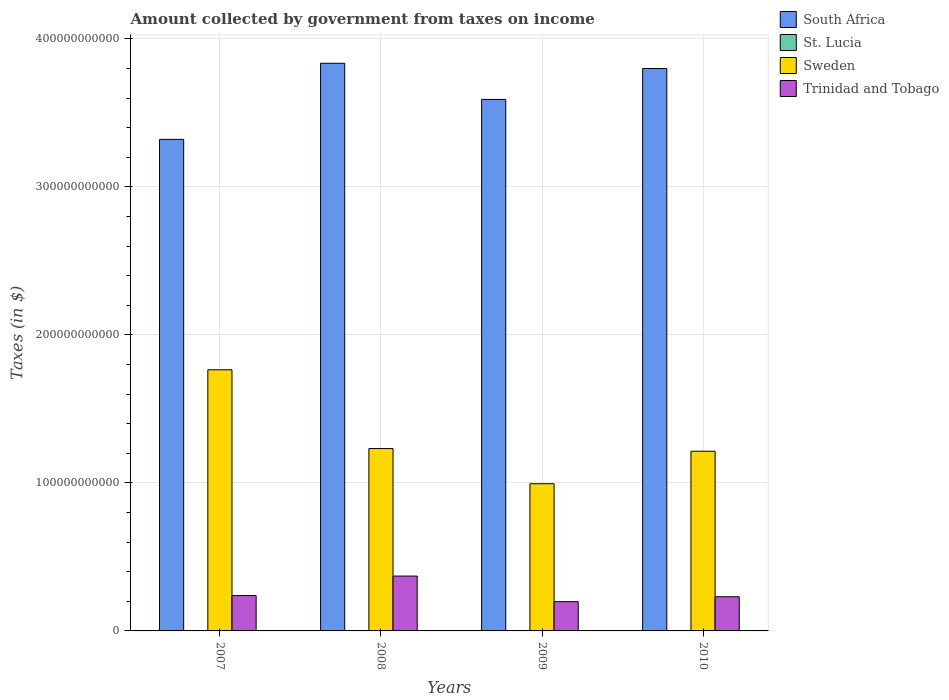How many groups of bars are there?
Offer a terse response. 4. Are the number of bars per tick equal to the number of legend labels?
Make the answer very short. Yes. Are the number of bars on each tick of the X-axis equal?
Ensure brevity in your answer.  Yes. How many bars are there on the 4th tick from the right?
Provide a succinct answer. 4. In how many cases, is the number of bars for a given year not equal to the number of legend labels?
Your answer should be compact. 0. What is the amount collected by government from taxes on income in St. Lucia in 2009?
Offer a terse response. 2.26e+08. Across all years, what is the maximum amount collected by government from taxes on income in Trinidad and Tobago?
Give a very brief answer. 3.71e+1. Across all years, what is the minimum amount collected by government from taxes on income in South Africa?
Offer a terse response. 3.32e+11. In which year was the amount collected by government from taxes on income in South Africa maximum?
Ensure brevity in your answer.  2008. What is the total amount collected by government from taxes on income in St. Lucia in the graph?
Provide a succinct answer. 8.52e+08. What is the difference between the amount collected by government from taxes on income in Sweden in 2007 and that in 2008?
Offer a very short reply. 5.32e+1. What is the difference between the amount collected by government from taxes on income in Sweden in 2010 and the amount collected by government from taxes on income in South Africa in 2009?
Provide a short and direct response. -2.38e+11. What is the average amount collected by government from taxes on income in South Africa per year?
Your response must be concise. 3.64e+11. In the year 2007, what is the difference between the amount collected by government from taxes on income in Trinidad and Tobago and amount collected by government from taxes on income in Sweden?
Provide a succinct answer. -1.53e+11. In how many years, is the amount collected by government from taxes on income in Trinidad and Tobago greater than 280000000000 $?
Offer a very short reply. 0. What is the ratio of the amount collected by government from taxes on income in Trinidad and Tobago in 2007 to that in 2009?
Keep it short and to the point. 1.21. What is the difference between the highest and the second highest amount collected by government from taxes on income in South Africa?
Make the answer very short. 3.54e+09. What is the difference between the highest and the lowest amount collected by government from taxes on income in Trinidad and Tobago?
Your answer should be compact. 1.73e+1. In how many years, is the amount collected by government from taxes on income in South Africa greater than the average amount collected by government from taxes on income in South Africa taken over all years?
Provide a succinct answer. 2. Is the sum of the amount collected by government from taxes on income in St. Lucia in 2009 and 2010 greater than the maximum amount collected by government from taxes on income in Sweden across all years?
Provide a short and direct response. No. What does the 4th bar from the left in 2008 represents?
Your answer should be very brief. Trinidad and Tobago. What does the 3rd bar from the right in 2010 represents?
Offer a very short reply. St. Lucia. Is it the case that in every year, the sum of the amount collected by government from taxes on income in Trinidad and Tobago and amount collected by government from taxes on income in South Africa is greater than the amount collected by government from taxes on income in Sweden?
Provide a short and direct response. Yes. How many bars are there?
Provide a succinct answer. 16. Are all the bars in the graph horizontal?
Provide a succinct answer. No. What is the difference between two consecutive major ticks on the Y-axis?
Your answer should be very brief. 1.00e+11. Does the graph contain any zero values?
Your answer should be compact. No. Where does the legend appear in the graph?
Offer a very short reply. Top right. What is the title of the graph?
Ensure brevity in your answer.  Amount collected by government from taxes on income. What is the label or title of the X-axis?
Offer a terse response. Years. What is the label or title of the Y-axis?
Your answer should be very brief. Taxes (in $). What is the Taxes (in $) of South Africa in 2007?
Keep it short and to the point. 3.32e+11. What is the Taxes (in $) in St. Lucia in 2007?
Provide a succinct answer. 1.77e+08. What is the Taxes (in $) in Sweden in 2007?
Your answer should be compact. 1.76e+11. What is the Taxes (in $) in Trinidad and Tobago in 2007?
Offer a terse response. 2.39e+1. What is the Taxes (in $) in South Africa in 2008?
Your answer should be very brief. 3.83e+11. What is the Taxes (in $) of St. Lucia in 2008?
Keep it short and to the point. 2.26e+08. What is the Taxes (in $) of Sweden in 2008?
Your answer should be compact. 1.23e+11. What is the Taxes (in $) in Trinidad and Tobago in 2008?
Offer a very short reply. 3.71e+1. What is the Taxes (in $) in South Africa in 2009?
Your answer should be compact. 3.59e+11. What is the Taxes (in $) of St. Lucia in 2009?
Your answer should be compact. 2.26e+08. What is the Taxes (in $) of Sweden in 2009?
Give a very brief answer. 9.94e+1. What is the Taxes (in $) in Trinidad and Tobago in 2009?
Your answer should be very brief. 1.98e+1. What is the Taxes (in $) of South Africa in 2010?
Provide a short and direct response. 3.80e+11. What is the Taxes (in $) of St. Lucia in 2010?
Make the answer very short. 2.23e+08. What is the Taxes (in $) in Sweden in 2010?
Offer a terse response. 1.21e+11. What is the Taxes (in $) in Trinidad and Tobago in 2010?
Offer a terse response. 2.31e+1. Across all years, what is the maximum Taxes (in $) of South Africa?
Provide a succinct answer. 3.83e+11. Across all years, what is the maximum Taxes (in $) of St. Lucia?
Offer a terse response. 2.26e+08. Across all years, what is the maximum Taxes (in $) of Sweden?
Your answer should be compact. 1.76e+11. Across all years, what is the maximum Taxes (in $) of Trinidad and Tobago?
Provide a short and direct response. 3.71e+1. Across all years, what is the minimum Taxes (in $) of South Africa?
Ensure brevity in your answer.  3.32e+11. Across all years, what is the minimum Taxes (in $) of St. Lucia?
Your response must be concise. 1.77e+08. Across all years, what is the minimum Taxes (in $) in Sweden?
Give a very brief answer. 9.94e+1. Across all years, what is the minimum Taxes (in $) of Trinidad and Tobago?
Ensure brevity in your answer.  1.98e+1. What is the total Taxes (in $) in South Africa in the graph?
Your answer should be very brief. 1.45e+12. What is the total Taxes (in $) in St. Lucia in the graph?
Keep it short and to the point. 8.52e+08. What is the total Taxes (in $) in Sweden in the graph?
Make the answer very short. 5.20e+11. What is the total Taxes (in $) in Trinidad and Tobago in the graph?
Your response must be concise. 1.04e+11. What is the difference between the Taxes (in $) of South Africa in 2007 and that in 2008?
Ensure brevity in your answer.  -5.14e+1. What is the difference between the Taxes (in $) in St. Lucia in 2007 and that in 2008?
Your answer should be very brief. -4.91e+07. What is the difference between the Taxes (in $) of Sweden in 2007 and that in 2008?
Your answer should be compact. 5.32e+1. What is the difference between the Taxes (in $) in Trinidad and Tobago in 2007 and that in 2008?
Your response must be concise. -1.32e+1. What is the difference between the Taxes (in $) in South Africa in 2007 and that in 2009?
Offer a terse response. -2.70e+1. What is the difference between the Taxes (in $) of St. Lucia in 2007 and that in 2009?
Your answer should be compact. -4.97e+07. What is the difference between the Taxes (in $) in Sweden in 2007 and that in 2009?
Offer a very short reply. 7.70e+1. What is the difference between the Taxes (in $) of Trinidad and Tobago in 2007 and that in 2009?
Make the answer very short. 4.14e+09. What is the difference between the Taxes (in $) in South Africa in 2007 and that in 2010?
Your answer should be very brief. -4.79e+1. What is the difference between the Taxes (in $) in St. Lucia in 2007 and that in 2010?
Offer a very short reply. -4.66e+07. What is the difference between the Taxes (in $) in Sweden in 2007 and that in 2010?
Make the answer very short. 5.50e+1. What is the difference between the Taxes (in $) of Trinidad and Tobago in 2007 and that in 2010?
Keep it short and to the point. 8.19e+08. What is the difference between the Taxes (in $) of South Africa in 2008 and that in 2009?
Your answer should be very brief. 2.44e+1. What is the difference between the Taxes (in $) of St. Lucia in 2008 and that in 2009?
Your answer should be compact. -6.00e+05. What is the difference between the Taxes (in $) in Sweden in 2008 and that in 2009?
Give a very brief answer. 2.38e+1. What is the difference between the Taxes (in $) in Trinidad and Tobago in 2008 and that in 2009?
Ensure brevity in your answer.  1.73e+1. What is the difference between the Taxes (in $) in South Africa in 2008 and that in 2010?
Ensure brevity in your answer.  3.54e+09. What is the difference between the Taxes (in $) of St. Lucia in 2008 and that in 2010?
Your answer should be compact. 2.50e+06. What is the difference between the Taxes (in $) of Sweden in 2008 and that in 2010?
Keep it short and to the point. 1.82e+09. What is the difference between the Taxes (in $) in Trinidad and Tobago in 2008 and that in 2010?
Offer a very short reply. 1.40e+1. What is the difference between the Taxes (in $) of South Africa in 2009 and that in 2010?
Give a very brief answer. -2.09e+1. What is the difference between the Taxes (in $) in St. Lucia in 2009 and that in 2010?
Your answer should be very brief. 3.10e+06. What is the difference between the Taxes (in $) of Sweden in 2009 and that in 2010?
Offer a very short reply. -2.20e+1. What is the difference between the Taxes (in $) of Trinidad and Tobago in 2009 and that in 2010?
Your answer should be compact. -3.32e+09. What is the difference between the Taxes (in $) of South Africa in 2007 and the Taxes (in $) of St. Lucia in 2008?
Keep it short and to the point. 3.32e+11. What is the difference between the Taxes (in $) in South Africa in 2007 and the Taxes (in $) in Sweden in 2008?
Your answer should be compact. 2.09e+11. What is the difference between the Taxes (in $) in South Africa in 2007 and the Taxes (in $) in Trinidad and Tobago in 2008?
Offer a terse response. 2.95e+11. What is the difference between the Taxes (in $) in St. Lucia in 2007 and the Taxes (in $) in Sweden in 2008?
Your answer should be compact. -1.23e+11. What is the difference between the Taxes (in $) of St. Lucia in 2007 and the Taxes (in $) of Trinidad and Tobago in 2008?
Ensure brevity in your answer.  -3.69e+1. What is the difference between the Taxes (in $) of Sweden in 2007 and the Taxes (in $) of Trinidad and Tobago in 2008?
Make the answer very short. 1.39e+11. What is the difference between the Taxes (in $) of South Africa in 2007 and the Taxes (in $) of St. Lucia in 2009?
Keep it short and to the point. 3.32e+11. What is the difference between the Taxes (in $) of South Africa in 2007 and the Taxes (in $) of Sweden in 2009?
Give a very brief answer. 2.33e+11. What is the difference between the Taxes (in $) in South Africa in 2007 and the Taxes (in $) in Trinidad and Tobago in 2009?
Your response must be concise. 3.12e+11. What is the difference between the Taxes (in $) of St. Lucia in 2007 and the Taxes (in $) of Sweden in 2009?
Offer a very short reply. -9.93e+1. What is the difference between the Taxes (in $) of St. Lucia in 2007 and the Taxes (in $) of Trinidad and Tobago in 2009?
Offer a very short reply. -1.96e+1. What is the difference between the Taxes (in $) in Sweden in 2007 and the Taxes (in $) in Trinidad and Tobago in 2009?
Keep it short and to the point. 1.57e+11. What is the difference between the Taxes (in $) in South Africa in 2007 and the Taxes (in $) in St. Lucia in 2010?
Offer a very short reply. 3.32e+11. What is the difference between the Taxes (in $) in South Africa in 2007 and the Taxes (in $) in Sweden in 2010?
Make the answer very short. 2.11e+11. What is the difference between the Taxes (in $) of South Africa in 2007 and the Taxes (in $) of Trinidad and Tobago in 2010?
Your answer should be compact. 3.09e+11. What is the difference between the Taxes (in $) of St. Lucia in 2007 and the Taxes (in $) of Sweden in 2010?
Give a very brief answer. -1.21e+11. What is the difference between the Taxes (in $) of St. Lucia in 2007 and the Taxes (in $) of Trinidad and Tobago in 2010?
Your answer should be compact. -2.29e+1. What is the difference between the Taxes (in $) in Sweden in 2007 and the Taxes (in $) in Trinidad and Tobago in 2010?
Keep it short and to the point. 1.53e+11. What is the difference between the Taxes (in $) in South Africa in 2008 and the Taxes (in $) in St. Lucia in 2009?
Ensure brevity in your answer.  3.83e+11. What is the difference between the Taxes (in $) of South Africa in 2008 and the Taxes (in $) of Sweden in 2009?
Your answer should be very brief. 2.84e+11. What is the difference between the Taxes (in $) of South Africa in 2008 and the Taxes (in $) of Trinidad and Tobago in 2009?
Your response must be concise. 3.64e+11. What is the difference between the Taxes (in $) in St. Lucia in 2008 and the Taxes (in $) in Sweden in 2009?
Offer a very short reply. -9.92e+1. What is the difference between the Taxes (in $) of St. Lucia in 2008 and the Taxes (in $) of Trinidad and Tobago in 2009?
Your response must be concise. -1.95e+1. What is the difference between the Taxes (in $) of Sweden in 2008 and the Taxes (in $) of Trinidad and Tobago in 2009?
Provide a succinct answer. 1.03e+11. What is the difference between the Taxes (in $) in South Africa in 2008 and the Taxes (in $) in St. Lucia in 2010?
Ensure brevity in your answer.  3.83e+11. What is the difference between the Taxes (in $) in South Africa in 2008 and the Taxes (in $) in Sweden in 2010?
Your answer should be very brief. 2.62e+11. What is the difference between the Taxes (in $) in South Africa in 2008 and the Taxes (in $) in Trinidad and Tobago in 2010?
Make the answer very short. 3.60e+11. What is the difference between the Taxes (in $) of St. Lucia in 2008 and the Taxes (in $) of Sweden in 2010?
Offer a very short reply. -1.21e+11. What is the difference between the Taxes (in $) of St. Lucia in 2008 and the Taxes (in $) of Trinidad and Tobago in 2010?
Offer a very short reply. -2.28e+1. What is the difference between the Taxes (in $) of Sweden in 2008 and the Taxes (in $) of Trinidad and Tobago in 2010?
Offer a terse response. 1.00e+11. What is the difference between the Taxes (in $) in South Africa in 2009 and the Taxes (in $) in St. Lucia in 2010?
Offer a terse response. 3.59e+11. What is the difference between the Taxes (in $) of South Africa in 2009 and the Taxes (in $) of Sweden in 2010?
Give a very brief answer. 2.38e+11. What is the difference between the Taxes (in $) in South Africa in 2009 and the Taxes (in $) in Trinidad and Tobago in 2010?
Keep it short and to the point. 3.36e+11. What is the difference between the Taxes (in $) in St. Lucia in 2009 and the Taxes (in $) in Sweden in 2010?
Provide a succinct answer. -1.21e+11. What is the difference between the Taxes (in $) of St. Lucia in 2009 and the Taxes (in $) of Trinidad and Tobago in 2010?
Offer a very short reply. -2.28e+1. What is the difference between the Taxes (in $) of Sweden in 2009 and the Taxes (in $) of Trinidad and Tobago in 2010?
Your response must be concise. 7.64e+1. What is the average Taxes (in $) of South Africa per year?
Offer a terse response. 3.64e+11. What is the average Taxes (in $) of St. Lucia per year?
Give a very brief answer. 2.13e+08. What is the average Taxes (in $) of Sweden per year?
Provide a succinct answer. 1.30e+11. What is the average Taxes (in $) of Trinidad and Tobago per year?
Keep it short and to the point. 2.59e+1. In the year 2007, what is the difference between the Taxes (in $) in South Africa and Taxes (in $) in St. Lucia?
Your answer should be very brief. 3.32e+11. In the year 2007, what is the difference between the Taxes (in $) of South Africa and Taxes (in $) of Sweden?
Make the answer very short. 1.56e+11. In the year 2007, what is the difference between the Taxes (in $) of South Africa and Taxes (in $) of Trinidad and Tobago?
Offer a very short reply. 3.08e+11. In the year 2007, what is the difference between the Taxes (in $) of St. Lucia and Taxes (in $) of Sweden?
Make the answer very short. -1.76e+11. In the year 2007, what is the difference between the Taxes (in $) of St. Lucia and Taxes (in $) of Trinidad and Tobago?
Your answer should be compact. -2.37e+1. In the year 2007, what is the difference between the Taxes (in $) in Sweden and Taxes (in $) in Trinidad and Tobago?
Your answer should be very brief. 1.53e+11. In the year 2008, what is the difference between the Taxes (in $) in South Africa and Taxes (in $) in St. Lucia?
Your answer should be compact. 3.83e+11. In the year 2008, what is the difference between the Taxes (in $) in South Africa and Taxes (in $) in Sweden?
Give a very brief answer. 2.60e+11. In the year 2008, what is the difference between the Taxes (in $) of South Africa and Taxes (in $) of Trinidad and Tobago?
Your answer should be very brief. 3.46e+11. In the year 2008, what is the difference between the Taxes (in $) in St. Lucia and Taxes (in $) in Sweden?
Offer a very short reply. -1.23e+11. In the year 2008, what is the difference between the Taxes (in $) of St. Lucia and Taxes (in $) of Trinidad and Tobago?
Your response must be concise. -3.68e+1. In the year 2008, what is the difference between the Taxes (in $) in Sweden and Taxes (in $) in Trinidad and Tobago?
Ensure brevity in your answer.  8.61e+1. In the year 2009, what is the difference between the Taxes (in $) in South Africa and Taxes (in $) in St. Lucia?
Give a very brief answer. 3.59e+11. In the year 2009, what is the difference between the Taxes (in $) of South Africa and Taxes (in $) of Sweden?
Give a very brief answer. 2.60e+11. In the year 2009, what is the difference between the Taxes (in $) in South Africa and Taxes (in $) in Trinidad and Tobago?
Your answer should be compact. 3.39e+11. In the year 2009, what is the difference between the Taxes (in $) of St. Lucia and Taxes (in $) of Sweden?
Ensure brevity in your answer.  -9.92e+1. In the year 2009, what is the difference between the Taxes (in $) in St. Lucia and Taxes (in $) in Trinidad and Tobago?
Provide a succinct answer. -1.95e+1. In the year 2009, what is the difference between the Taxes (in $) in Sweden and Taxes (in $) in Trinidad and Tobago?
Ensure brevity in your answer.  7.97e+1. In the year 2010, what is the difference between the Taxes (in $) of South Africa and Taxes (in $) of St. Lucia?
Your response must be concise. 3.80e+11. In the year 2010, what is the difference between the Taxes (in $) in South Africa and Taxes (in $) in Sweden?
Offer a terse response. 2.59e+11. In the year 2010, what is the difference between the Taxes (in $) of South Africa and Taxes (in $) of Trinidad and Tobago?
Offer a very short reply. 3.57e+11. In the year 2010, what is the difference between the Taxes (in $) in St. Lucia and Taxes (in $) in Sweden?
Your answer should be compact. -1.21e+11. In the year 2010, what is the difference between the Taxes (in $) of St. Lucia and Taxes (in $) of Trinidad and Tobago?
Give a very brief answer. -2.28e+1. In the year 2010, what is the difference between the Taxes (in $) in Sweden and Taxes (in $) in Trinidad and Tobago?
Your answer should be very brief. 9.83e+1. What is the ratio of the Taxes (in $) in South Africa in 2007 to that in 2008?
Offer a very short reply. 0.87. What is the ratio of the Taxes (in $) of St. Lucia in 2007 to that in 2008?
Make the answer very short. 0.78. What is the ratio of the Taxes (in $) of Sweden in 2007 to that in 2008?
Provide a short and direct response. 1.43. What is the ratio of the Taxes (in $) of Trinidad and Tobago in 2007 to that in 2008?
Keep it short and to the point. 0.64. What is the ratio of the Taxes (in $) in South Africa in 2007 to that in 2009?
Offer a terse response. 0.92. What is the ratio of the Taxes (in $) in St. Lucia in 2007 to that in 2009?
Offer a very short reply. 0.78. What is the ratio of the Taxes (in $) of Sweden in 2007 to that in 2009?
Your answer should be compact. 1.77. What is the ratio of the Taxes (in $) of Trinidad and Tobago in 2007 to that in 2009?
Keep it short and to the point. 1.21. What is the ratio of the Taxes (in $) in South Africa in 2007 to that in 2010?
Your response must be concise. 0.87. What is the ratio of the Taxes (in $) of St. Lucia in 2007 to that in 2010?
Provide a succinct answer. 0.79. What is the ratio of the Taxes (in $) in Sweden in 2007 to that in 2010?
Make the answer very short. 1.45. What is the ratio of the Taxes (in $) of Trinidad and Tobago in 2007 to that in 2010?
Provide a succinct answer. 1.04. What is the ratio of the Taxes (in $) in South Africa in 2008 to that in 2009?
Ensure brevity in your answer.  1.07. What is the ratio of the Taxes (in $) in St. Lucia in 2008 to that in 2009?
Offer a very short reply. 1. What is the ratio of the Taxes (in $) of Sweden in 2008 to that in 2009?
Offer a very short reply. 1.24. What is the ratio of the Taxes (in $) of Trinidad and Tobago in 2008 to that in 2009?
Keep it short and to the point. 1.88. What is the ratio of the Taxes (in $) of South Africa in 2008 to that in 2010?
Provide a succinct answer. 1.01. What is the ratio of the Taxes (in $) of St. Lucia in 2008 to that in 2010?
Provide a short and direct response. 1.01. What is the ratio of the Taxes (in $) of Sweden in 2008 to that in 2010?
Make the answer very short. 1.01. What is the ratio of the Taxes (in $) of Trinidad and Tobago in 2008 to that in 2010?
Offer a very short reply. 1.61. What is the ratio of the Taxes (in $) of South Africa in 2009 to that in 2010?
Your answer should be compact. 0.94. What is the ratio of the Taxes (in $) of St. Lucia in 2009 to that in 2010?
Offer a very short reply. 1.01. What is the ratio of the Taxes (in $) of Sweden in 2009 to that in 2010?
Provide a short and direct response. 0.82. What is the ratio of the Taxes (in $) of Trinidad and Tobago in 2009 to that in 2010?
Your answer should be compact. 0.86. What is the difference between the highest and the second highest Taxes (in $) in South Africa?
Give a very brief answer. 3.54e+09. What is the difference between the highest and the second highest Taxes (in $) in St. Lucia?
Your response must be concise. 6.00e+05. What is the difference between the highest and the second highest Taxes (in $) of Sweden?
Keep it short and to the point. 5.32e+1. What is the difference between the highest and the second highest Taxes (in $) in Trinidad and Tobago?
Your answer should be compact. 1.32e+1. What is the difference between the highest and the lowest Taxes (in $) of South Africa?
Your response must be concise. 5.14e+1. What is the difference between the highest and the lowest Taxes (in $) in St. Lucia?
Provide a succinct answer. 4.97e+07. What is the difference between the highest and the lowest Taxes (in $) of Sweden?
Give a very brief answer. 7.70e+1. What is the difference between the highest and the lowest Taxes (in $) of Trinidad and Tobago?
Keep it short and to the point. 1.73e+1. 